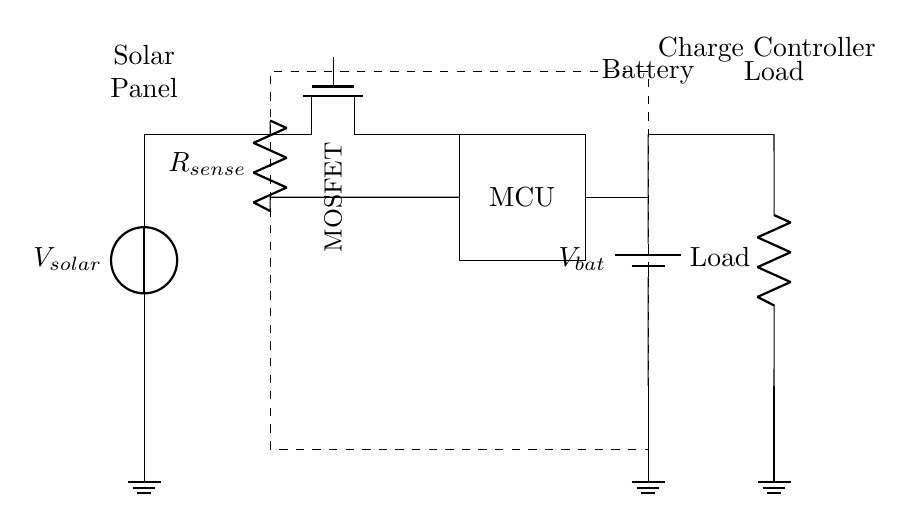What is the total number of components in the circuit? The circuit consists of a solar panel, a charge controller, a MOSFET, a microcontroller, a resistor, a battery, and a load. Counting these components gives a total of seven distinct components.
Answer: seven What type of MOSFET is used in the circuit? The diagram indicates the use of a Tnmos, which is typically a n-channel MOSFET. This is relevant for its application in switching and control within the charge controller.
Answer: Tnmos What is the role of the microcontroller in this circuit? The microcontroller (MCU) is responsible for managing the charging process, including controlling the MOSFET in response to battery voltage levels and optimizing efficiency.
Answer: managing charging What is the voltage source for the battery? The battery voltage is represented as V_bat in the diagram, showing that it serves as the voltage supply to power the connected load. The supply must match the load voltage requirements.
Answer: V_bat How does the resistor function in relation to the MOSFET? The resistor, labeled R_sense, is used to sense current flowing through the circuit. It provides feedback to the microcontroller about the charging current to prevent overcharging and manage battery health.
Answer: current sensing What is the purpose of the charge controller in this diagram? The charge controller regulates the voltage and current coming from the solar panel to the battery, ensuring safe charging conditions without damaging the battery, thus extending its lifespan.
Answer: regulate charging What type of load is connected to the circuit? The load type is denoted simply as Load in the diagram, but it can represent any device or circuit that consumes power from the battery, like lights or appliances in an off-grid system.
Answer: Load 